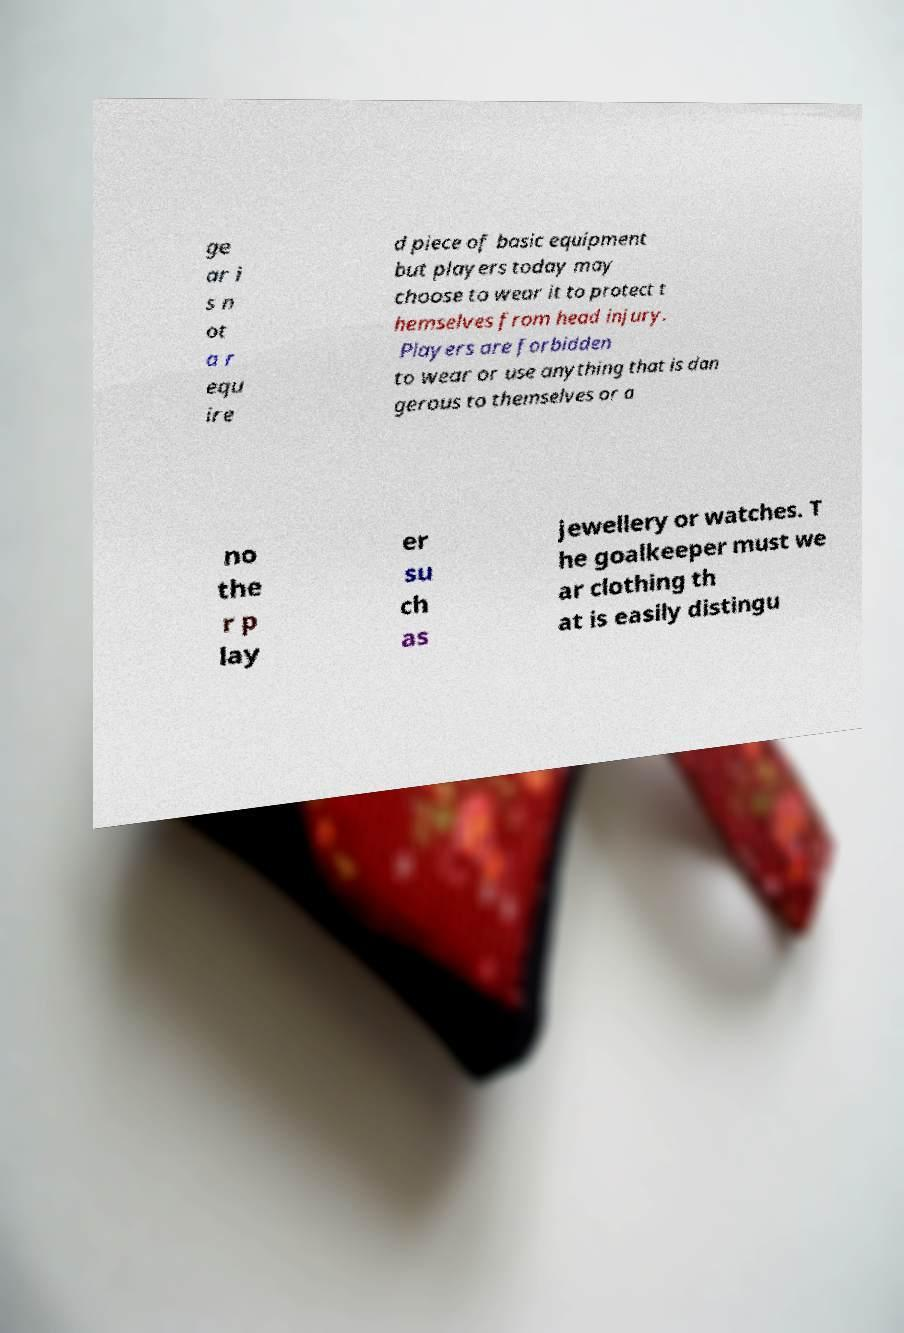What messages or text are displayed in this image? I need them in a readable, typed format. ge ar i s n ot a r equ ire d piece of basic equipment but players today may choose to wear it to protect t hemselves from head injury. Players are forbidden to wear or use anything that is dan gerous to themselves or a no the r p lay er su ch as jewellery or watches. T he goalkeeper must we ar clothing th at is easily distingu 